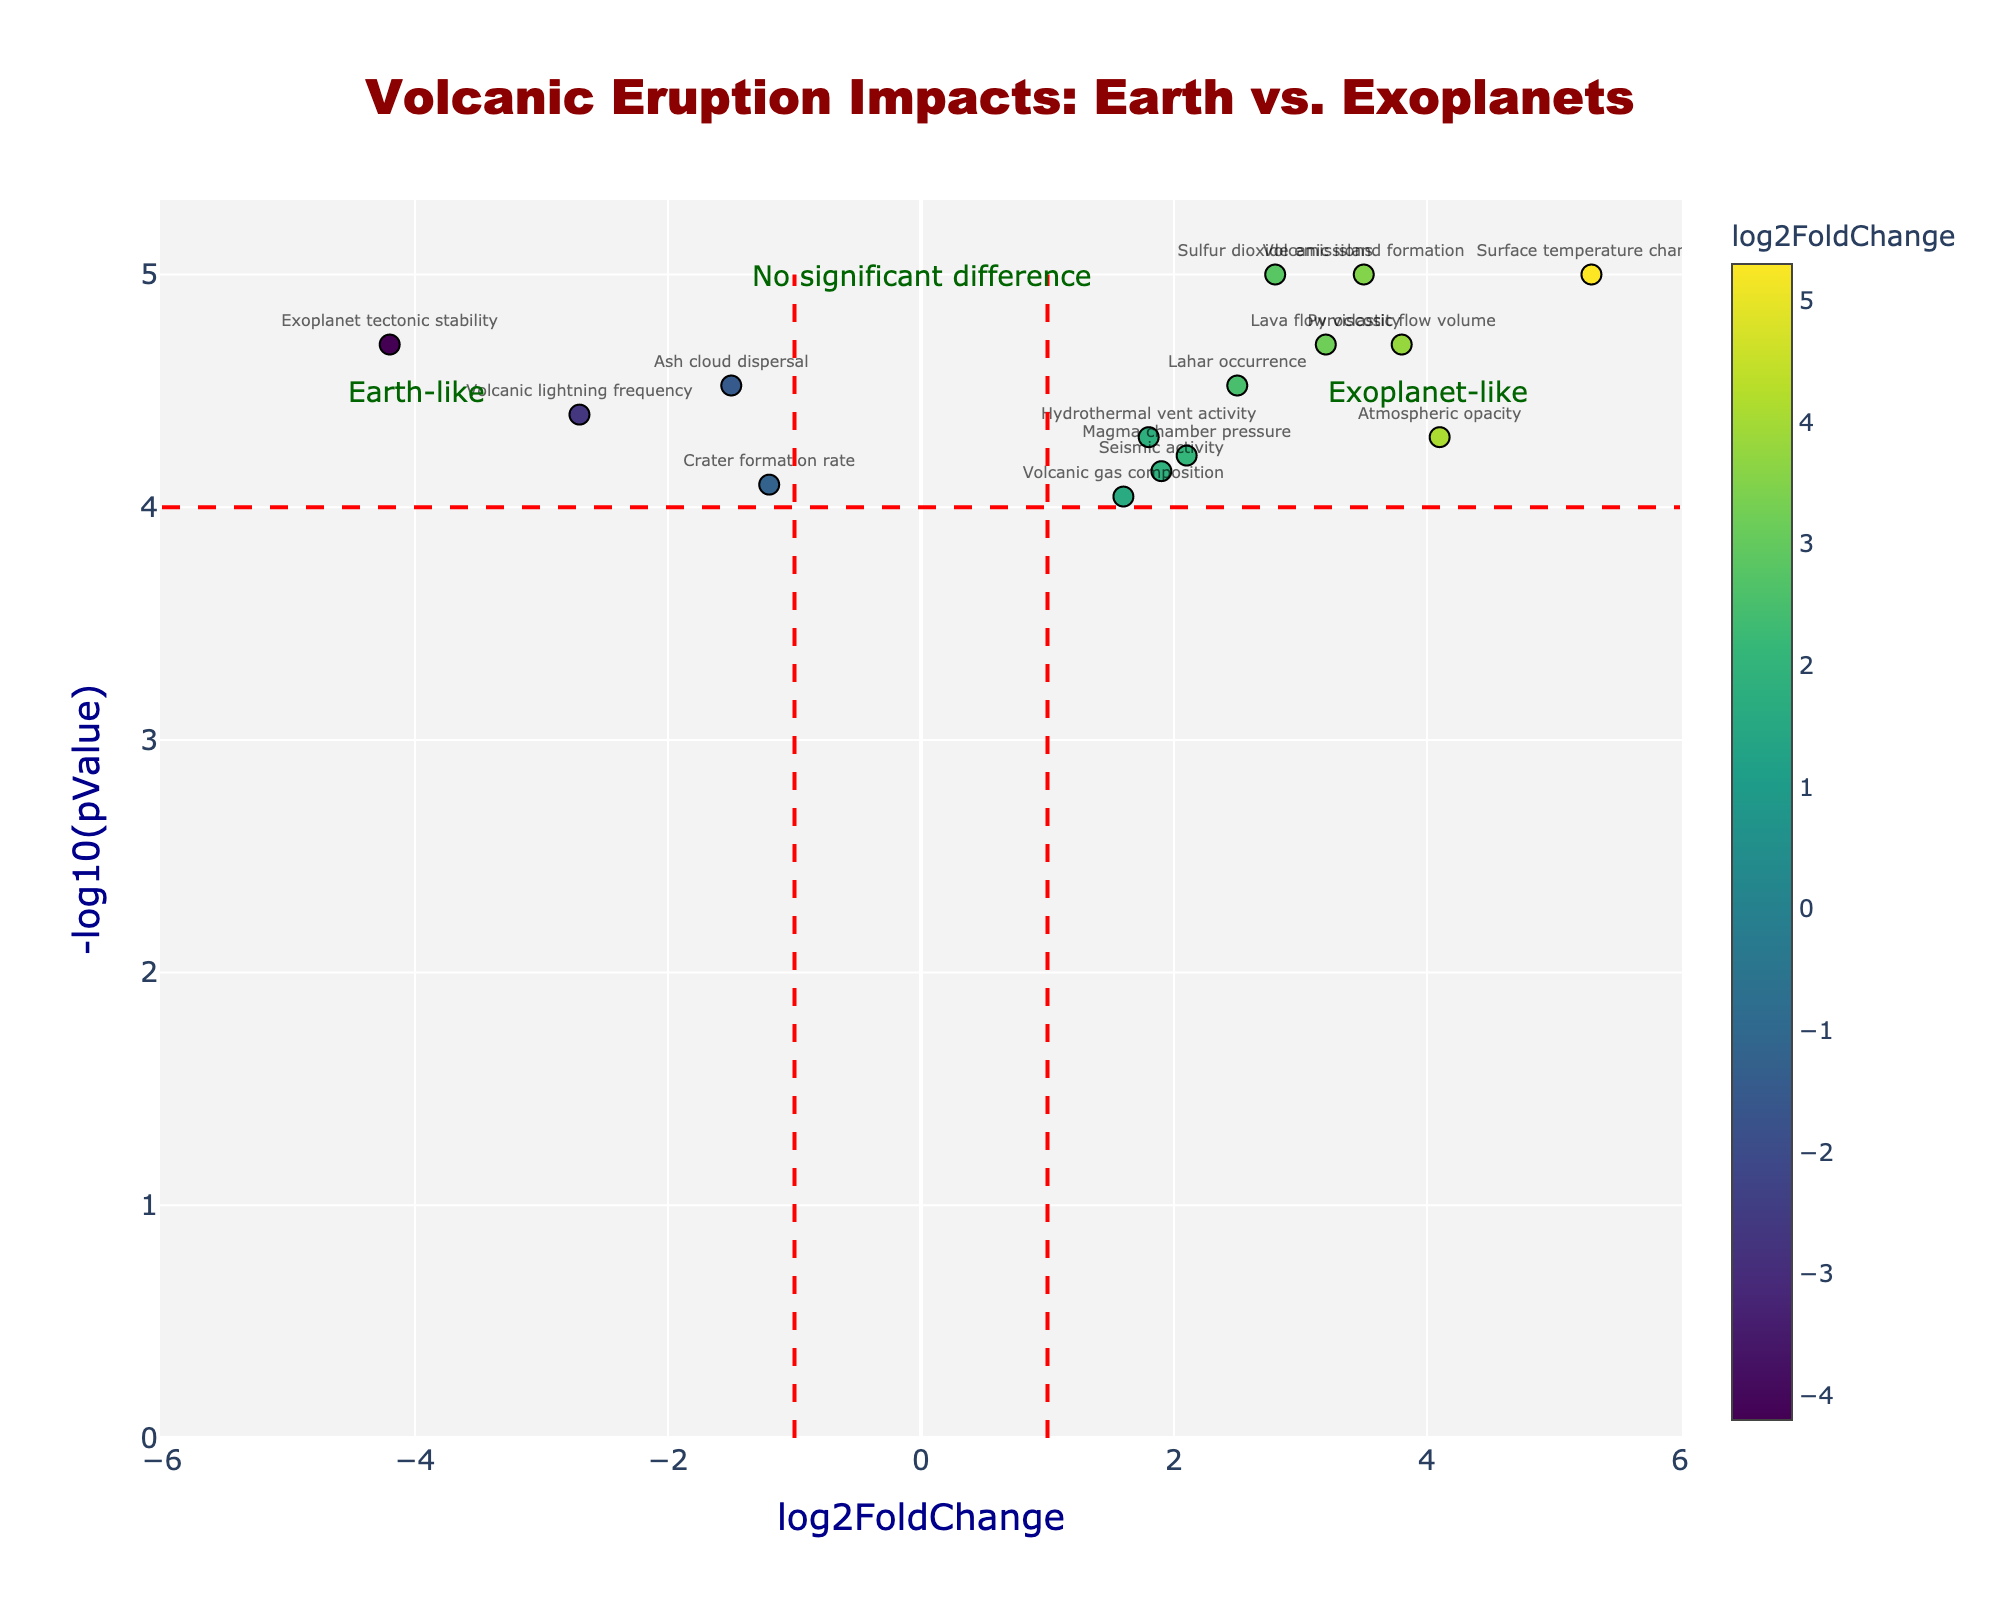What is the title of the figure? The title is found at the top of the chart and is often larger and bolder compared to other text. Here, it reads: "Volcanic Eruption Impacts: Earth vs. Exoplanets".
Answer: Volcanic Eruption Impacts: Earth vs. Exoplanets What do the x-axis and y-axis represent in this figure? The labels on the axes describe what they represent. The x-axis is labeled "log2FoldChange," and the y-axis is labeled "-log10(pValue)".
Answer: x-axis: log2FoldChange, y-axis: -log10(pValue) How many variables are shown in the figure? Each variable corresponds to a unique marker in the scatter plot with a textual label next to it. Counting these markers/labeled points gives us the total number of variables.
Answer: 15 Which variable has the highest log2FoldChange? By looking at the variable with the highest x-axis value (log2FoldChange), we can identify it visually. "Surface temperature change" has the highest x-axis value among all variables.
Answer: Surface temperature change What does a data point with negative log2FoldChange signify in this context? Data points with negative log2FoldChange are to the left of the vertical line through zero. They represent factors which decrease in exoplanets compared to Earth. For example, "Exoplanet tectonic stability" has a noticeably negative log2FoldChange.
Answer: Factors decrease in exoplanets What is the p-value threshold indicated by the horizontal red dashed line? The horizontal red dashed line across the plot represents a significant p-value threshold. The y-axis value where this line is drawn indicates the threshold. In this case, it is at -log10(pValue) = 4.
Answer: 0.0001 Which variable has the lowest p-value in the figure? The lowest p-value will be the variable with the highest -log10(pValue) value on the y-axis. "Surface temperature change" is the variable with the highest -log10(pValue) value.
Answer: Surface temperature change What is the log2FoldChange and p-value for "Ash cloud dispersal"? By locating the "Ash cloud dispersal" label on the plot, we can read its coordinates on the axes. From the hover text, we get log2FoldChange: -1.5 and -log10(pValue): 4.52, so pValue is 0.00003.
Answer: log2FoldChange: -1.5, pValue: 0.00003 Which variables fall into the "Earth-like" category based on the detailed annotations? The annotation "Earth-like" is to the right of the vertical dashed line at -1, and to the left of the vertical line at 1, and below 4 on y-axis. Variables within this box are: "Seismic activity", "Sulfur dioxide emissions", "Lahar occurrence", "Hydrothermal vent activity".
Answer: Seismic activity, Sulfur dioxide emissions, Lahar occurrence, Hydrothermal vent activity Which variable shows a higher impact on exoplanets in comparison to Earth? Variables with high positive log2FoldChange have a higher impact on exoplanets. "Surface temperature change" is the variable with the highest positive log2FoldChange, indicating greater impact on exoplanets compared to Earth.
Answer: Surface temperature change 